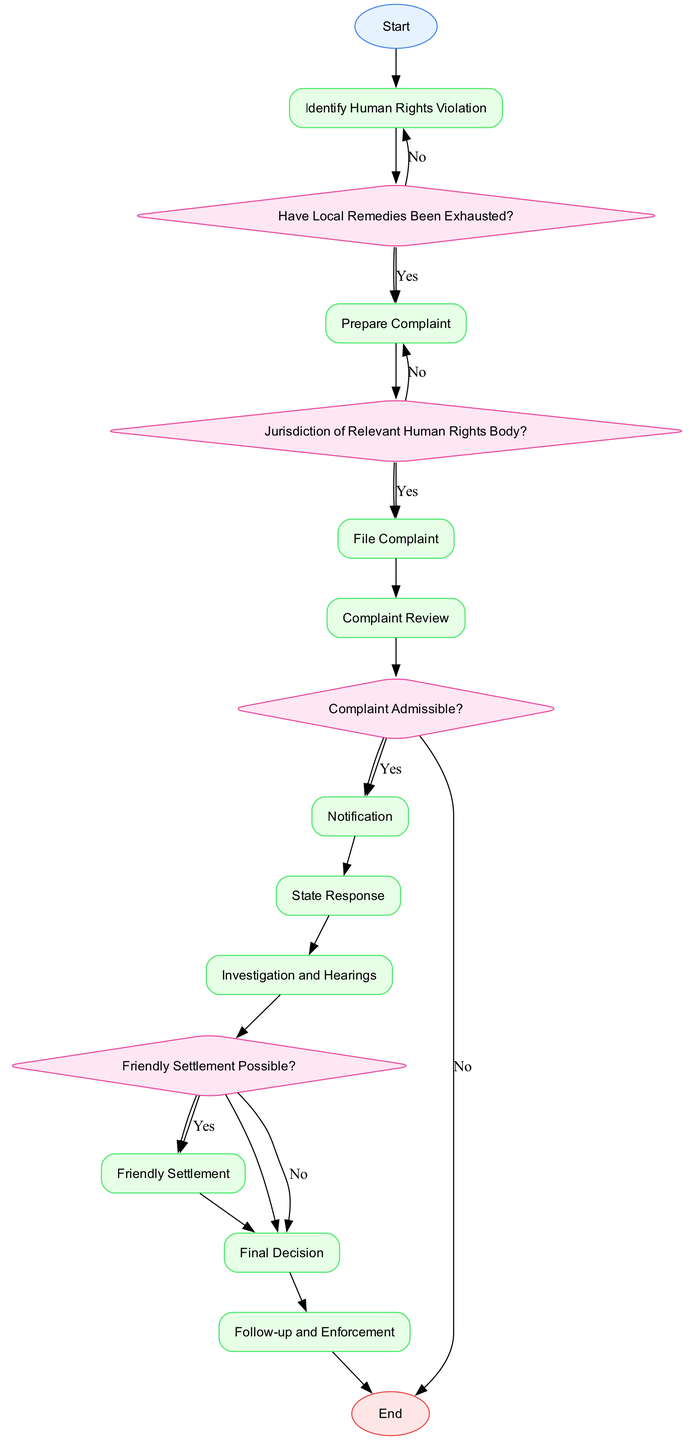what is the first step in the process? The first step in the diagram is 'Start', which indicates the initiation of the process. This is represented by node 1, which is the entry point of the flowchart.
Answer: Start how many decision nodes are there in the diagram? The diagram contains five decision nodes. Each decision node corresponds to a point where a choice must be made, impacting the subsequent path in the flowchart. These are nodes 3, 5, 8, and 12.
Answer: Five what is the final step in the process? The final step, represented by node 16, indicates the conclusion of the process, which is marked as 'End'. This shows that all processes have been completed.
Answer: End what happens if local remedies have not been exhausted? If local remedies have not been exhausted, the flowchart indicates that the process loops back to 'Identify Human Rights Violation', meaning the process must restart to address this issue properly.
Answer: Restart process how many steps come after the complaint review step? After the 'Complaint Review' step, which is node 7, there are three steps: 'Complaint Admissible', 'Notification', and 'State Response'. This shows the direct flow of actions that follow the review.
Answer: Three what should be done after the final decision is made? After the 'Final Decision' (node 14) is issued by the human rights body, the next step is 'Follow-up and Enforcement', which involves monitoring the implementation of that decision.
Answer: Follow-up and Enforcement is a friendly settlement possible after investigation and hearings? Yes, the process indicates that determining if a friendly settlement is possible occurs right after the investigation and hearings (node 11), based on the decision made at node 12.
Answer: Yes what are the consequences if the complaint is deemed inadmissible? If the complaint is deemed inadmissible (as indicated in node 8), the diagram shows that the process leads directly to 'End', suggesting that no further actions can be taken on that complaint.
Answer: End 